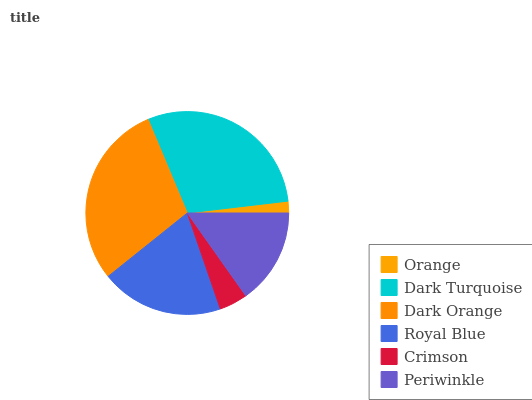Is Orange the minimum?
Answer yes or no. Yes. Is Dark Turquoise the maximum?
Answer yes or no. Yes. Is Dark Orange the minimum?
Answer yes or no. No. Is Dark Orange the maximum?
Answer yes or no. No. Is Dark Turquoise greater than Dark Orange?
Answer yes or no. Yes. Is Dark Orange less than Dark Turquoise?
Answer yes or no. Yes. Is Dark Orange greater than Dark Turquoise?
Answer yes or no. No. Is Dark Turquoise less than Dark Orange?
Answer yes or no. No. Is Royal Blue the high median?
Answer yes or no. Yes. Is Periwinkle the low median?
Answer yes or no. Yes. Is Dark Turquoise the high median?
Answer yes or no. No. Is Dark Turquoise the low median?
Answer yes or no. No. 